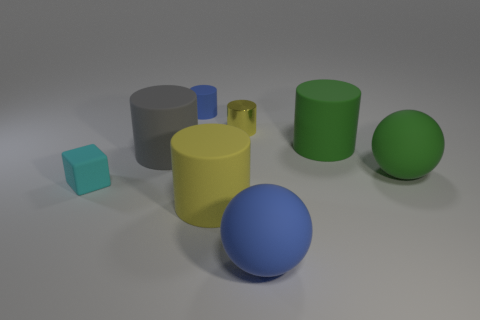Subtract all brown balls. How many yellow cylinders are left? 2 Subtract all large gray cylinders. How many cylinders are left? 4 Subtract all green cylinders. How many cylinders are left? 4 Add 1 big blue rubber things. How many objects exist? 9 Subtract all green cylinders. Subtract all gray blocks. How many cylinders are left? 4 Subtract all cylinders. How many objects are left? 3 Add 3 small matte cylinders. How many small matte cylinders exist? 4 Subtract 0 purple spheres. How many objects are left? 8 Subtract all blue things. Subtract all gray metallic spheres. How many objects are left? 6 Add 7 green rubber objects. How many green rubber objects are left? 9 